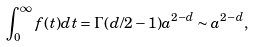Convert formula to latex. <formula><loc_0><loc_0><loc_500><loc_500>\int _ { 0 } ^ { \infty } f ( t ) d t = \Gamma ( d / 2 - 1 ) a ^ { 2 - d } \sim a ^ { 2 - d } ,</formula> 